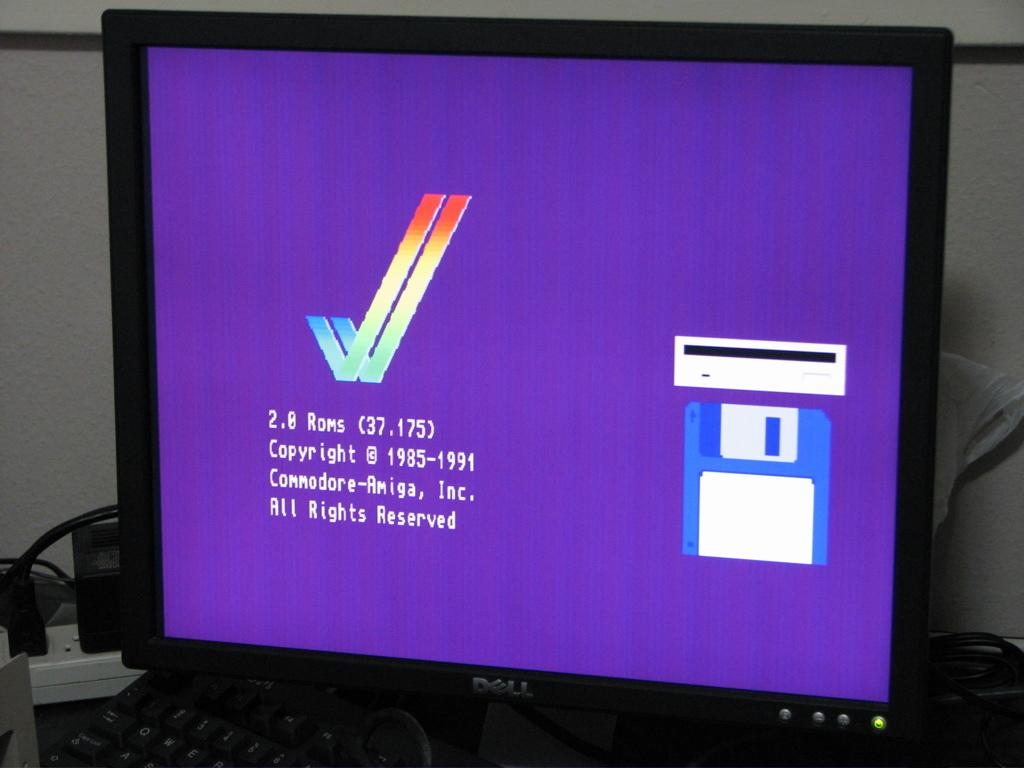<image>
Write a terse but informative summary of the picture. a dell monitor with a screen shot for commodore amiga software 